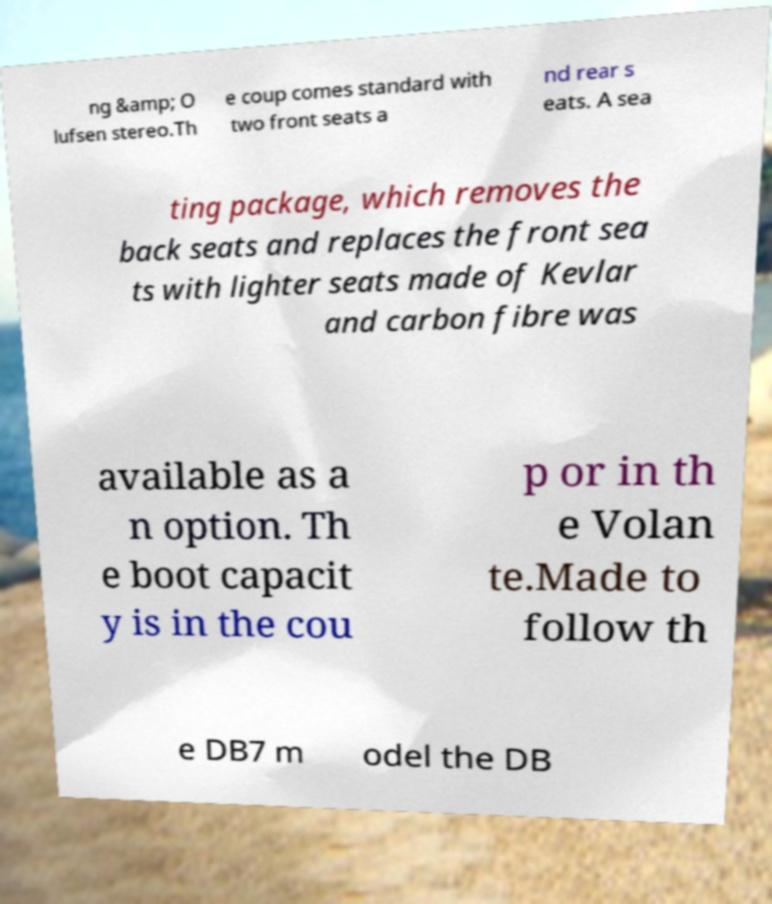There's text embedded in this image that I need extracted. Can you transcribe it verbatim? ng &amp; O lufsen stereo.Th e coup comes standard with two front seats a nd rear s eats. A sea ting package, which removes the back seats and replaces the front sea ts with lighter seats made of Kevlar and carbon fibre was available as a n option. Th e boot capacit y is in the cou p or in th e Volan te.Made to follow th e DB7 m odel the DB 